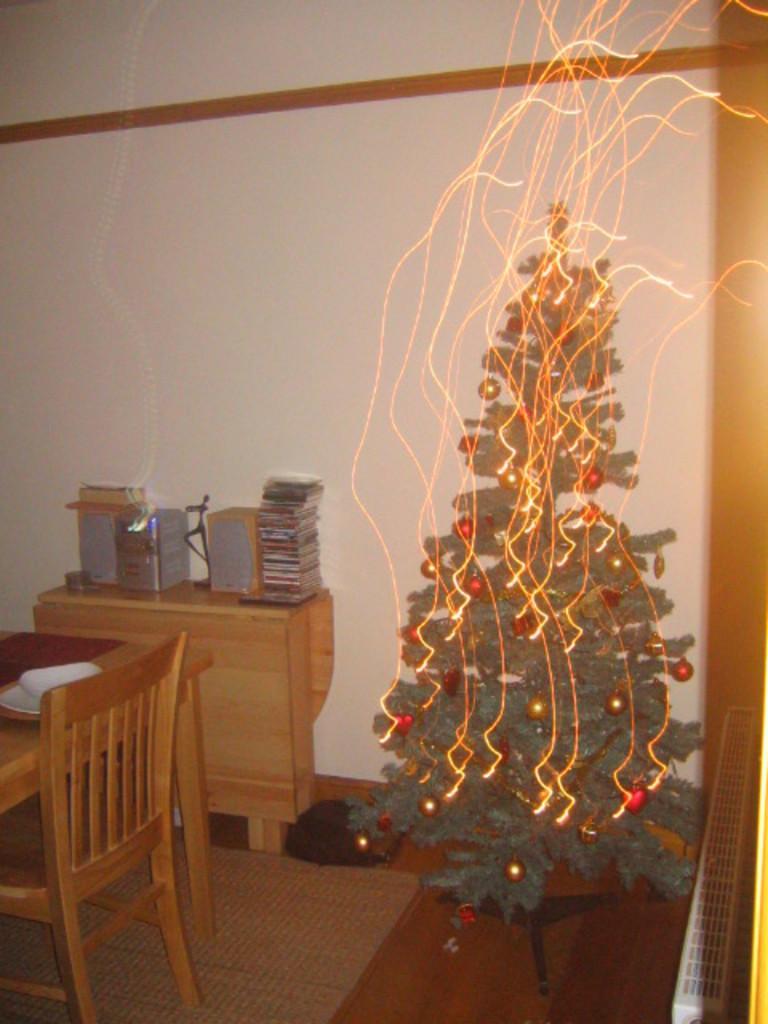Can you describe this image briefly? On the left side of the image there is a table with plates. And also there is a chair. Beside the table there is a cupboard. On the cupboard there are speakers and also there are few other items. On the right side of the image there is a Christmas tree with decorative things. Behind that there is a wall. On the right corner of the image there is a white color object. On the floor there is a floor mat. 